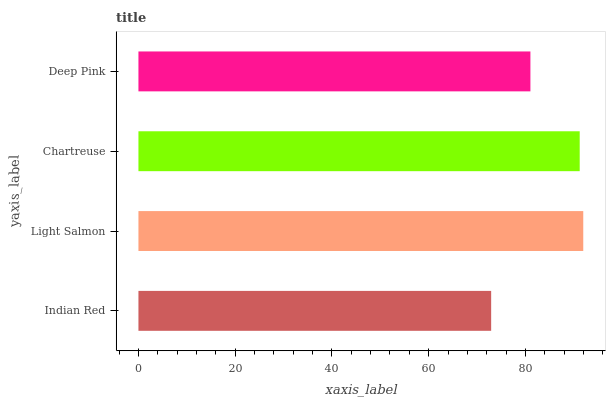Is Indian Red the minimum?
Answer yes or no. Yes. Is Light Salmon the maximum?
Answer yes or no. Yes. Is Chartreuse the minimum?
Answer yes or no. No. Is Chartreuse the maximum?
Answer yes or no. No. Is Light Salmon greater than Chartreuse?
Answer yes or no. Yes. Is Chartreuse less than Light Salmon?
Answer yes or no. Yes. Is Chartreuse greater than Light Salmon?
Answer yes or no. No. Is Light Salmon less than Chartreuse?
Answer yes or no. No. Is Chartreuse the high median?
Answer yes or no. Yes. Is Deep Pink the low median?
Answer yes or no. Yes. Is Deep Pink the high median?
Answer yes or no. No. Is Light Salmon the low median?
Answer yes or no. No. 